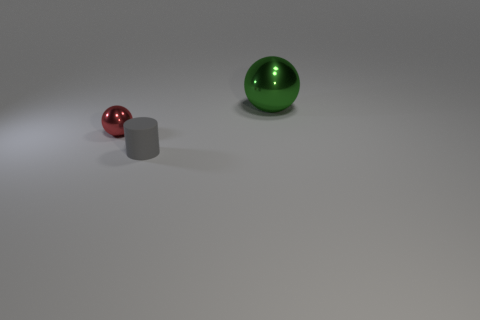Add 3 large cylinders. How many objects exist? 6 Subtract all green balls. How many balls are left? 1 Subtract all spheres. How many objects are left? 1 Subtract 1 spheres. How many spheres are left? 1 Add 2 small purple balls. How many small purple balls exist? 2 Subtract 0 brown balls. How many objects are left? 3 Subtract all blue balls. Subtract all red cubes. How many balls are left? 2 Subtract all red blocks. How many green cylinders are left? 0 Subtract all tiny gray rubber cylinders. Subtract all tiny red metal things. How many objects are left? 1 Add 1 matte cylinders. How many matte cylinders are left? 2 